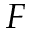Convert formula to latex. <formula><loc_0><loc_0><loc_500><loc_500>F</formula> 